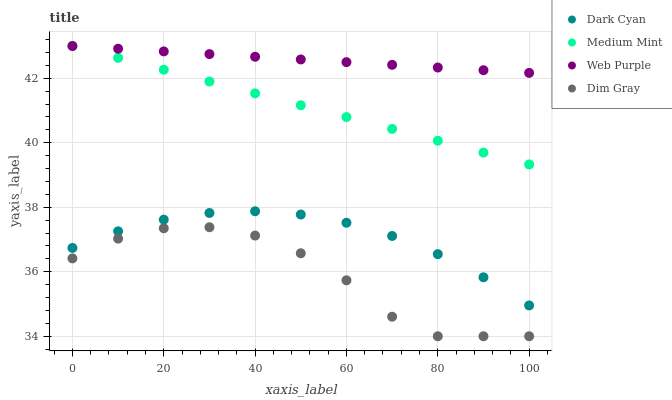Does Dim Gray have the minimum area under the curve?
Answer yes or no. Yes. Does Web Purple have the maximum area under the curve?
Answer yes or no. Yes. Does Medium Mint have the minimum area under the curve?
Answer yes or no. No. Does Medium Mint have the maximum area under the curve?
Answer yes or no. No. Is Medium Mint the smoothest?
Answer yes or no. Yes. Is Dim Gray the roughest?
Answer yes or no. Yes. Is Web Purple the smoothest?
Answer yes or no. No. Is Web Purple the roughest?
Answer yes or no. No. Does Dim Gray have the lowest value?
Answer yes or no. Yes. Does Medium Mint have the lowest value?
Answer yes or no. No. Does Web Purple have the highest value?
Answer yes or no. Yes. Does Dim Gray have the highest value?
Answer yes or no. No. Is Dim Gray less than Dark Cyan?
Answer yes or no. Yes. Is Web Purple greater than Dark Cyan?
Answer yes or no. Yes. Does Medium Mint intersect Web Purple?
Answer yes or no. Yes. Is Medium Mint less than Web Purple?
Answer yes or no. No. Is Medium Mint greater than Web Purple?
Answer yes or no. No. Does Dim Gray intersect Dark Cyan?
Answer yes or no. No. 